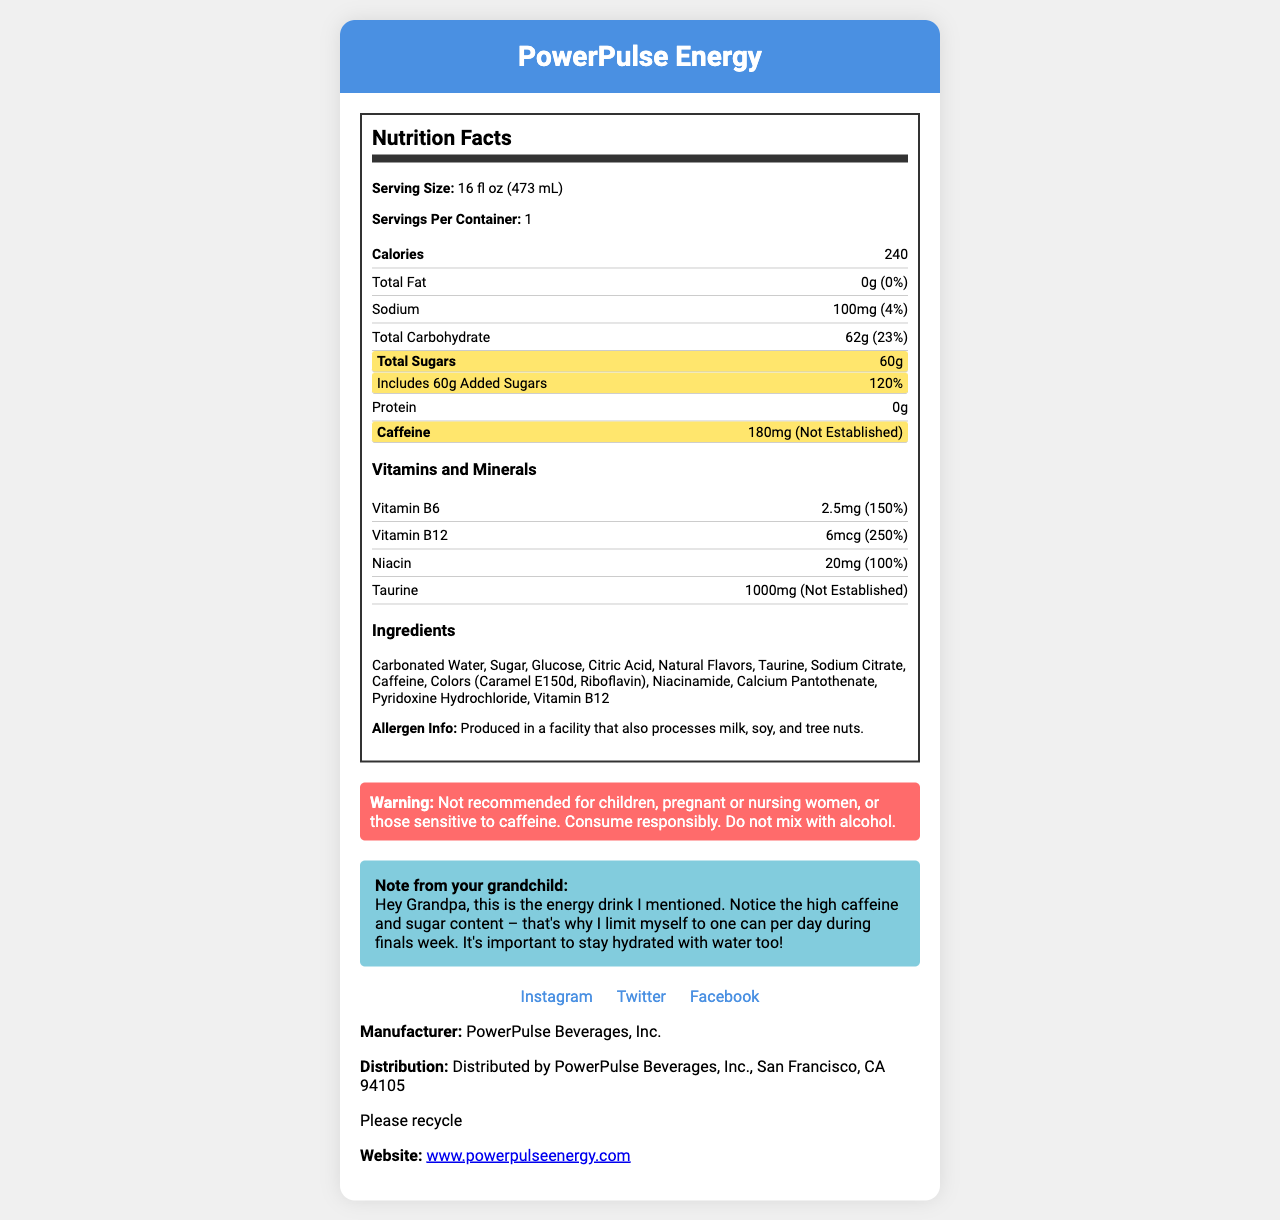what is the serving size of PowerPulse Energy? The serving size is explicitly mentioned as "16 fl oz (473 mL)" in the Nutrition Facts section of the document.
Answer: 16 fl oz (473 mL) how many calories are in one serving? The document states that one serving contains 240 calories.
Answer: 240 What is the amount of total sugars in one serving? The total amount of sugars in one serving is indicated to be 60g in the Nutrition Facts.
Answer: 60g what is the caffeine content in PowerPulse Energy? The document specifies that the caffeine content is 180mg per serving.
Answer: 180mg What percentage of the daily value is the Vitamin B12 content? The Vitamin B12 content is listed as having 250% of the daily value.
Answer: 250% How much sodium does one serving of PowerPulse Energy have? A. 50mg B. 100mg C. 150mg D. 200mg The amount of sodium per serving is provided as 100mg.
Answer: B What is the daily value percentage of added sugars in one serving? A. 80% B. 100% C. 120% The daily value percentage of added sugars is 120%.
Answer: C Is PowerPulse Energy recommended for children or pregnant women? The document contains a warning advising that the product is "Not recommended for children, pregnant or nursing women, or those sensitive to caffeine."
Answer: No Does PowerPulse Energy contain any protein? According to the Nutrition Facts, the product has 0g of protein.
Answer: No summarize the key nutritional information and warnings found on the PowerPulse Energy label. This summary encapsulates the critical nutritional elements such as calories, fat, sodium, carbohydrates, sugars, protein, caffeine, vitamins, and highlights the important health warnings provided in the document.
Answer: PowerPulse Energy has 240 calories per 16 fl oz serving. It contains 0g of fat, 100mg of sodium (4% DV), 62g of total carbohydrates (23% DV), 60g of total sugars (including 60g of added sugars, 120% DV), 0g of protein, and 180mg of caffeine. It also provides significant amounts of Vitamin B6 (150% DV) and Vitamin B12 (250% DV). Key warnings include that the drink is not recommended for children, pregnant/nursing women, or those sensitive to caffeine. It should not be mixed with alcohol, and consumption should be responsible. Are there any artificial colors listed in the ingredients? If so, which ones? The document lists "Caramel E150d" and "Riboflavin" as artificial colors in the ingredients.
Answer: Yes, Caramel E150d, Riboflavin How many servings are there in one container of PowerPulse Energy? The document states that there is 1 serving per container.
Answer: 1 Who manufactures PowerPulse Energy? The manufacturer is mentioned as PowerPulse Beverages, Inc.
Answer: PowerPulse Beverages, Inc. What is the primary sweetener used in PowerPulse Energy? The ingredients list "Sugar" and "Glucose" as the primary sweeteners.
Answer: Sugar and Glucose What is the amount of taurine in one serving? The Nutrition Facts section specifies that there is 1000mg of Taurine per serving.
Answer: 1000mg Based on the information in the document, what is the maximum daily intake of PowerPulse Energy that a college student can have if they limit themselves to one can per day during finals week? The student note specifically mentions limiting themselves to one can per day.
Answer: 1 can per day What is the exact location of the social media handles for PowerPulse Energy? The document provides the social media handles but not their exact URLs. The information includes: Instagram (@powerpulseenergy), Twitter (@PowerPulsedrink), and Facebook (PowerPulseEnergyDrink), but it does not include the URLs.
Answer: Not enough information 